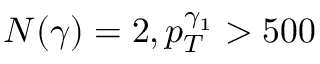Convert formula to latex. <formula><loc_0><loc_0><loc_500><loc_500>N ( \gamma ) = 2 , p _ { T } ^ { \gamma _ { 1 } } > 5 0 0</formula> 